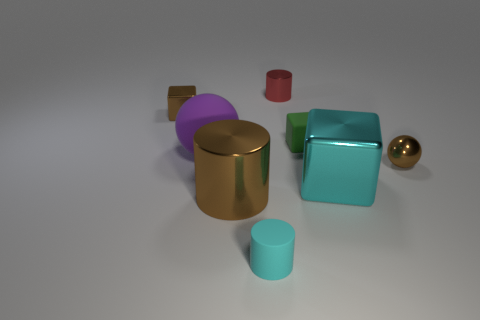What number of other objects are the same shape as the tiny red thing?
Your answer should be compact. 2. There is a matte thing that is both behind the brown metal cylinder and left of the small red metallic cylinder; how big is it?
Your answer should be very brief. Large. How many shiny objects are either red things or brown cylinders?
Provide a short and direct response. 2. There is a large shiny object that is in front of the cyan metal block; does it have the same shape as the tiny brown object that is on the right side of the matte cylinder?
Make the answer very short. No. Are there any cylinders made of the same material as the brown sphere?
Make the answer very short. Yes. The rubber ball has what color?
Provide a short and direct response. Purple. What size is the brown shiny thing to the left of the big ball?
Provide a short and direct response. Small. How many tiny spheres are the same color as the large metal cylinder?
Offer a very short reply. 1. There is a tiny brown shiny thing on the left side of the large cyan metallic cube; are there any spheres that are behind it?
Your answer should be compact. No. Does the thing that is behind the small brown metal block have the same color as the tiny cylinder in front of the big cyan block?
Give a very brief answer. No. 